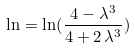<formula> <loc_0><loc_0><loc_500><loc_500>\ln = \ln ( \frac { 4 - { \lambda } ^ { 3 } } { 4 + 2 \, { \lambda } ^ { 3 } } )</formula> 